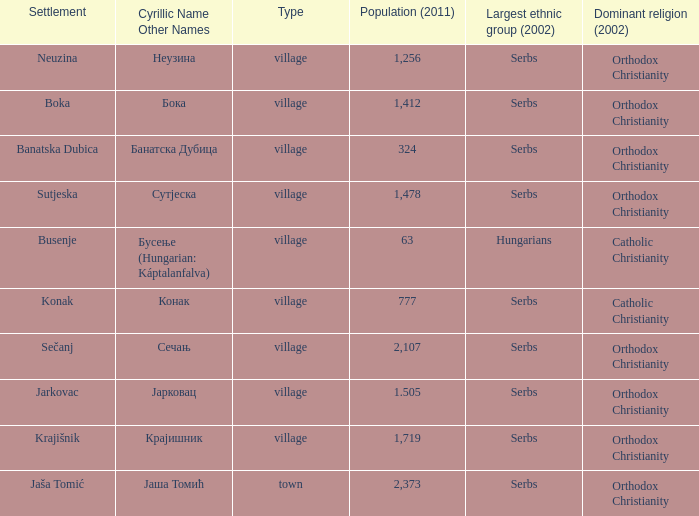The population is 2,107's dominant religion is? Orthodox Christianity. 